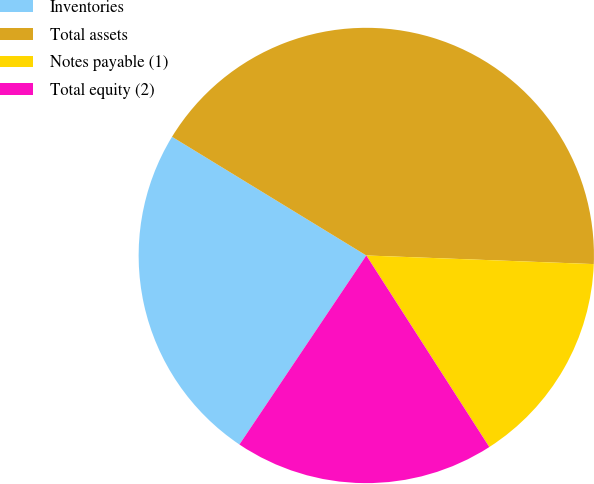<chart> <loc_0><loc_0><loc_500><loc_500><pie_chart><fcel>Inventories<fcel>Total assets<fcel>Notes payable (1)<fcel>Total equity (2)<nl><fcel>24.32%<fcel>41.87%<fcel>15.31%<fcel>18.49%<nl></chart> 